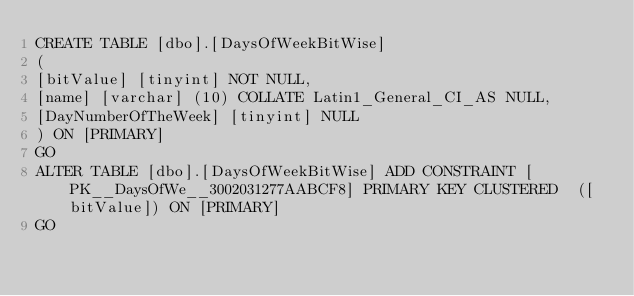Convert code to text. <code><loc_0><loc_0><loc_500><loc_500><_SQL_>CREATE TABLE [dbo].[DaysOfWeekBitWise]
(
[bitValue] [tinyint] NOT NULL,
[name] [varchar] (10) COLLATE Latin1_General_CI_AS NULL,
[DayNumberOfTheWeek] [tinyint] NULL
) ON [PRIMARY]
GO
ALTER TABLE [dbo].[DaysOfWeekBitWise] ADD CONSTRAINT [PK__DaysOfWe__3002031277AABCF8] PRIMARY KEY CLUSTERED  ([bitValue]) ON [PRIMARY]
GO
</code> 